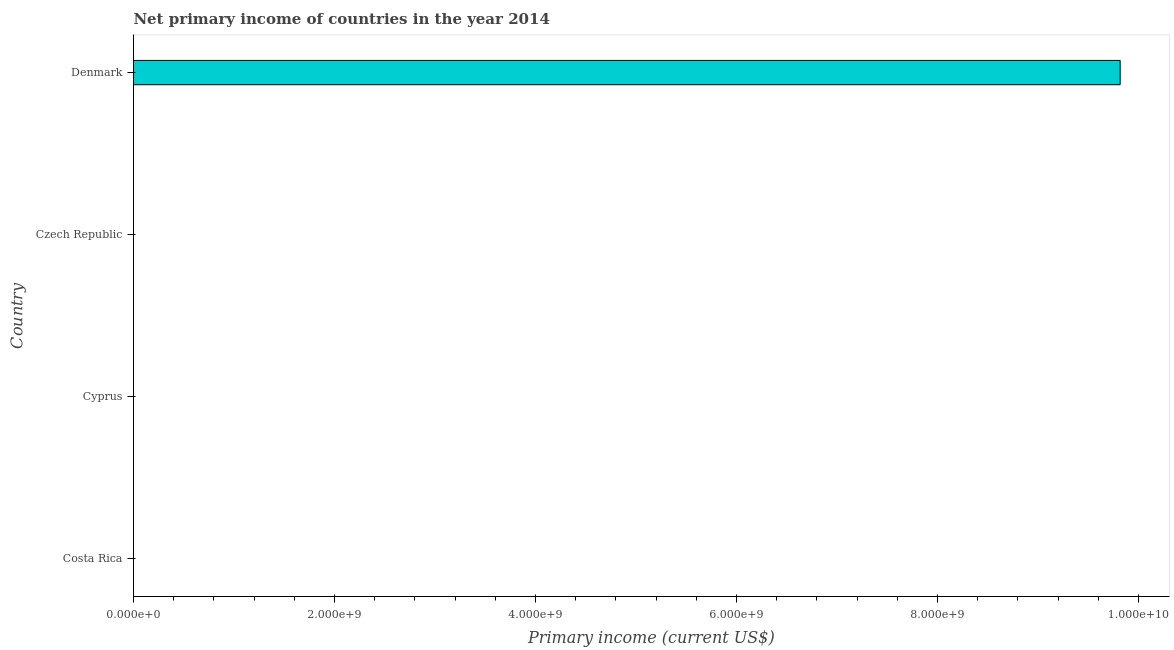Does the graph contain any zero values?
Make the answer very short. Yes. Does the graph contain grids?
Provide a short and direct response. No. What is the title of the graph?
Offer a very short reply. Net primary income of countries in the year 2014. What is the label or title of the X-axis?
Offer a very short reply. Primary income (current US$). What is the amount of primary income in Denmark?
Provide a short and direct response. 9.82e+09. Across all countries, what is the maximum amount of primary income?
Your answer should be compact. 9.82e+09. In which country was the amount of primary income maximum?
Make the answer very short. Denmark. What is the sum of the amount of primary income?
Provide a short and direct response. 9.82e+09. What is the average amount of primary income per country?
Offer a terse response. 2.45e+09. What is the difference between the highest and the lowest amount of primary income?
Offer a terse response. 9.82e+09. How many bars are there?
Your answer should be compact. 1. How many countries are there in the graph?
Provide a succinct answer. 4. What is the difference between two consecutive major ticks on the X-axis?
Keep it short and to the point. 2.00e+09. What is the Primary income (current US$) of Cyprus?
Ensure brevity in your answer.  0. What is the Primary income (current US$) of Denmark?
Provide a short and direct response. 9.82e+09. 